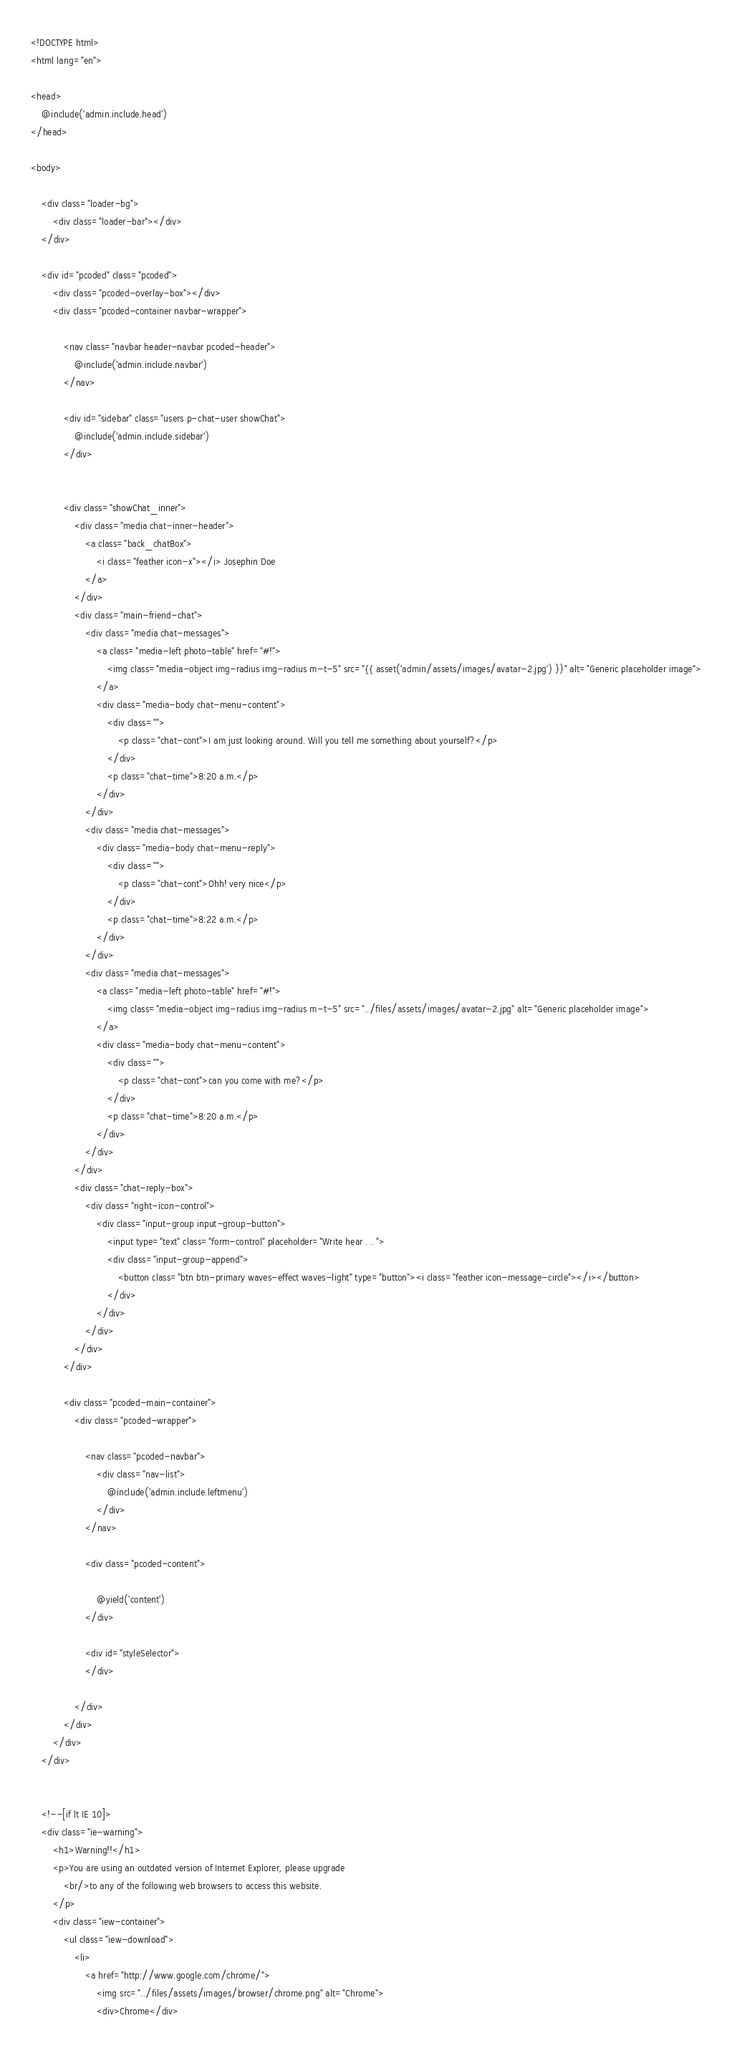<code> <loc_0><loc_0><loc_500><loc_500><_PHP_><!DOCTYPE html>
<html lang="en">

<head>
    @include('admin.include.head')
</head>

<body>

	<div class="loader-bg">
		<div class="loader-bar"></div>
	</div>

	<div id="pcoded" class="pcoded">
		<div class="pcoded-overlay-box"></div>
		<div class="pcoded-container navbar-wrapper">

			<nav class="navbar header-navbar pcoded-header">
				@include('admin.include.navbar')
			</nav>

			<div id="sidebar" class="users p-chat-user showChat">
				@include('admin.include.sidebar')
			</div>


			<div class="showChat_inner">
				<div class="media chat-inner-header">
					<a class="back_chatBox">
						<i class="feather icon-x"></i> Josephin Doe
					</a>
				</div>
				<div class="main-friend-chat">
					<div class="media chat-messages">
						<a class="media-left photo-table" href="#!">
							<img class="media-object img-radius img-radius m-t-5" src="{{ asset('admin/assets/images/avatar-2.jpg') }}" alt="Generic placeholder image">
						</a>
						<div class="media-body chat-menu-content">
							<div class="">
								<p class="chat-cont">I am just looking around. Will you tell me something about yourself?</p>
							</div>
							<p class="chat-time">8:20 a.m.</p>
						</div>
					</div>
					<div class="media chat-messages">
						<div class="media-body chat-menu-reply">
							<div class="">
								<p class="chat-cont">Ohh! very nice</p>
							</div>
							<p class="chat-time">8:22 a.m.</p>
						</div>
					</div>
					<div class="media chat-messages">
						<a class="media-left photo-table" href="#!">
							<img class="media-object img-radius img-radius m-t-5" src="../files/assets/images/avatar-2.jpg" alt="Generic placeholder image">
						</a>
						<div class="media-body chat-menu-content">
							<div class="">
								<p class="chat-cont">can you come with me?</p>
							</div>
							<p class="chat-time">8:20 a.m.</p>
						</div>
					</div>
				</div>
				<div class="chat-reply-box">
					<div class="right-icon-control">
						<div class="input-group input-group-button">
							<input type="text" class="form-control" placeholder="Write hear . . ">
							<div class="input-group-append">
								<button class="btn btn-primary waves-effect waves-light" type="button"><i class="feather icon-message-circle"></i></button>
							</div>
						</div>
					</div>
				</div>
			</div>

			<div class="pcoded-main-container">
				<div class="pcoded-wrapper">

					<nav class="pcoded-navbar">
						<div class="nav-list">
							@include('admin.include.leftmenu')
						</div>
					</nav>

					<div class="pcoded-content">

						@yield('content')
					</div>

					<div id="styleSelector">
					</div>

				</div>
			</div>
		</div>
	</div>


	<!--[if lt IE 10]>
    <div class="ie-warning">
        <h1>Warning!!</h1>
        <p>You are using an outdated version of Internet Explorer, please upgrade
            <br/>to any of the following web browsers to access this website.
        </p>
        <div class="iew-container">
            <ul class="iew-download">
                <li>
                    <a href="http://www.google.com/chrome/">
                        <img src="../files/assets/images/browser/chrome.png" alt="Chrome">
                        <div>Chrome</div></code> 